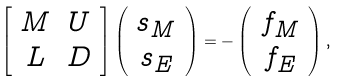<formula> <loc_0><loc_0><loc_500><loc_500>\left [ \begin{array} { c c } M & U \\ L & D \end{array} \right ] \left ( \begin{array} { c } s _ { M } \\ s _ { E } \end{array} \right ) = - \left ( \begin{array} { c } f _ { M } \\ f _ { E } \end{array} \right ) ,</formula> 